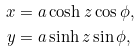<formula> <loc_0><loc_0><loc_500><loc_500>x & = a \cosh z \cos \phi , \\ y & = a \sinh z \sin \phi ,</formula> 